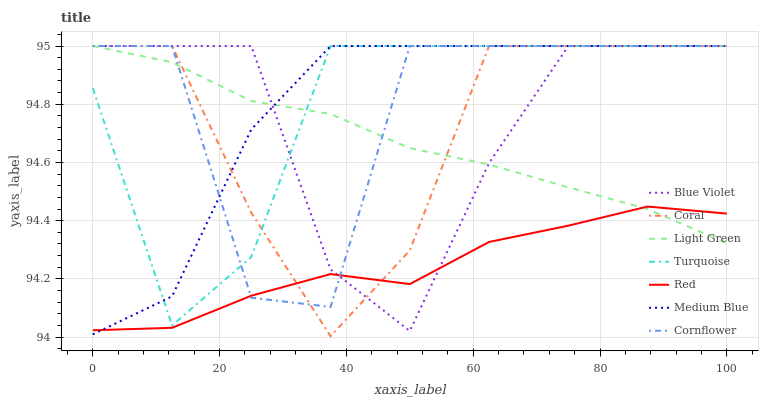Does Red have the minimum area under the curve?
Answer yes or no. Yes. Does Medium Blue have the maximum area under the curve?
Answer yes or no. Yes. Does Turquoise have the minimum area under the curve?
Answer yes or no. No. Does Turquoise have the maximum area under the curve?
Answer yes or no. No. Is Light Green the smoothest?
Answer yes or no. Yes. Is Cornflower the roughest?
Answer yes or no. Yes. Is Turquoise the smoothest?
Answer yes or no. No. Is Turquoise the roughest?
Answer yes or no. No. Does Coral have the lowest value?
Answer yes or no. Yes. Does Turquoise have the lowest value?
Answer yes or no. No. Does Light Green have the highest value?
Answer yes or no. Yes. Does Red have the highest value?
Answer yes or no. No. Is Red less than Turquoise?
Answer yes or no. Yes. Is Turquoise greater than Red?
Answer yes or no. Yes. Does Medium Blue intersect Blue Violet?
Answer yes or no. Yes. Is Medium Blue less than Blue Violet?
Answer yes or no. No. Is Medium Blue greater than Blue Violet?
Answer yes or no. No. Does Red intersect Turquoise?
Answer yes or no. No. 